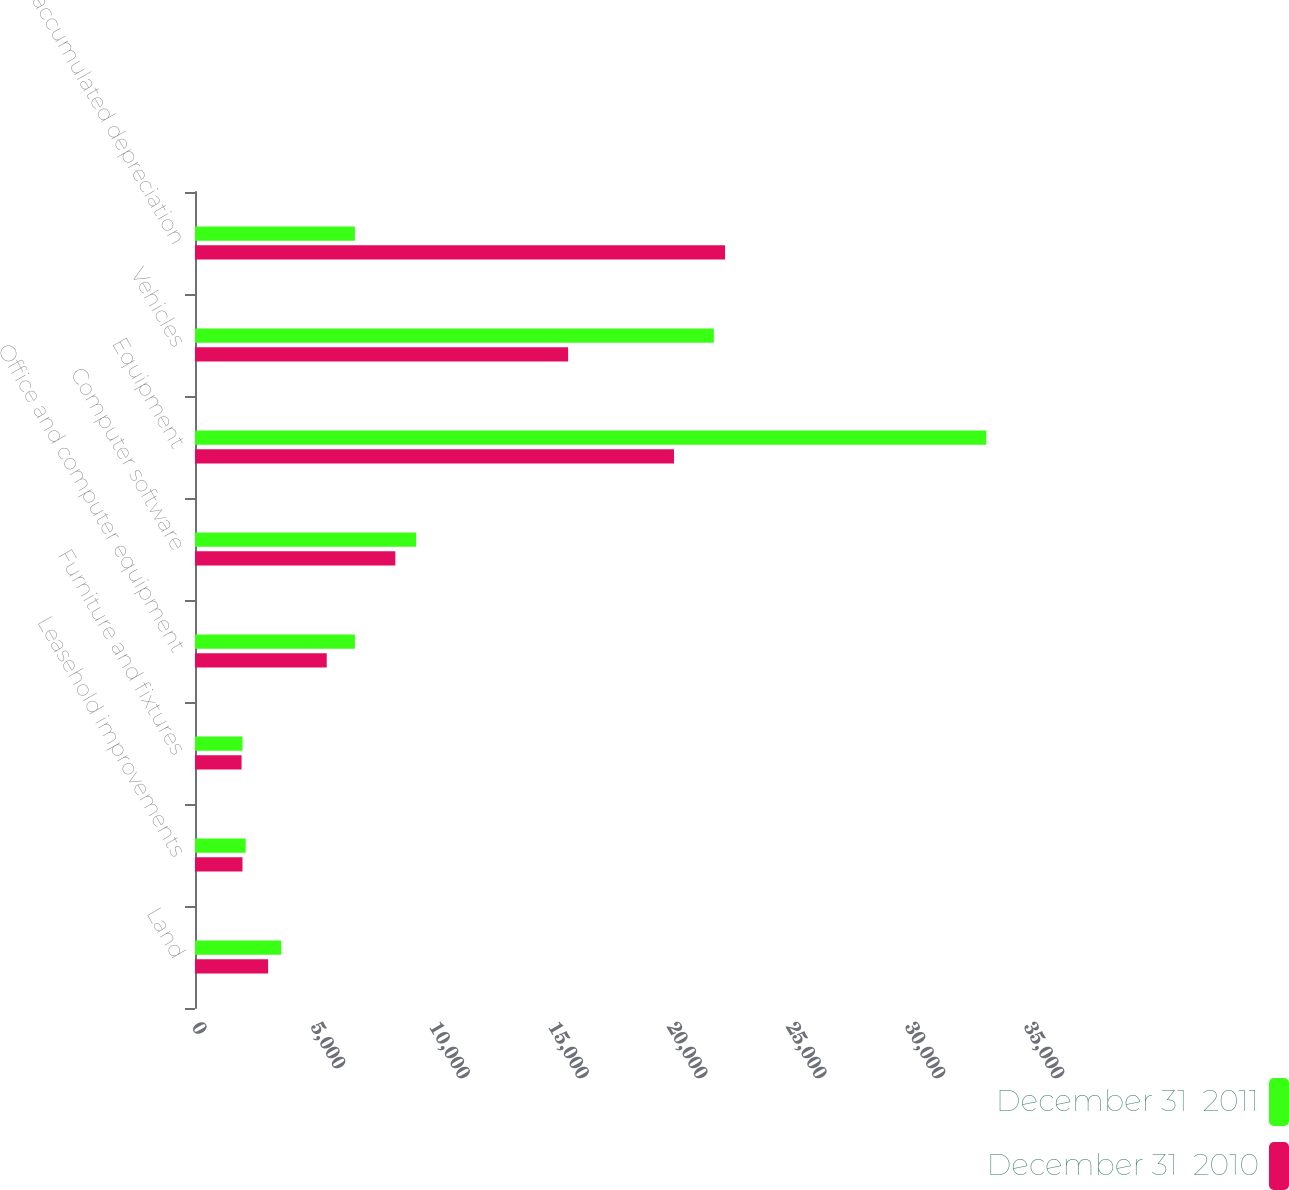<chart> <loc_0><loc_0><loc_500><loc_500><stacked_bar_chart><ecel><fcel>Land<fcel>Leasehold improvements<fcel>Furniture and fixtures<fcel>Office and computer equipment<fcel>Computer software<fcel>Equipment<fcel>Vehicles<fcel>Less accumulated depreciation<nl><fcel>December 31  2011<fcel>3626<fcel>2132<fcel>2000<fcel>6727<fcel>9303<fcel>33286<fcel>21827<fcel>6727<nl><fcel>December 31  2010<fcel>3076<fcel>1998<fcel>1959<fcel>5541<fcel>8428<fcel>20150<fcel>15696<fcel>22297<nl></chart> 